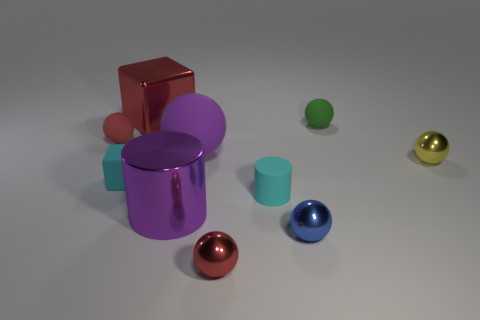Subtract all small yellow shiny spheres. How many spheres are left? 5 Subtract 1 spheres. How many spheres are left? 5 Subtract all yellow cylinders. How many red balls are left? 2 Subtract all red balls. How many balls are left? 4 Subtract all cylinders. How many objects are left? 8 Subtract all red balls. Subtract all gray cylinders. How many balls are left? 4 Add 9 big shiny blocks. How many big shiny blocks are left? 10 Add 5 large rubber things. How many large rubber things exist? 6 Subtract 0 red cylinders. How many objects are left? 10 Subtract all small red blocks. Subtract all big purple cylinders. How many objects are left? 9 